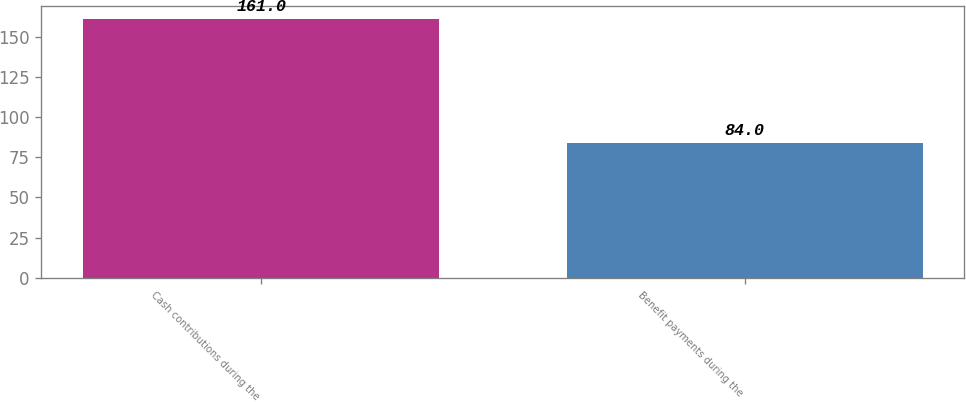Convert chart to OTSL. <chart><loc_0><loc_0><loc_500><loc_500><bar_chart><fcel>Cash contributions during the<fcel>Benefit payments during the<nl><fcel>161<fcel>84<nl></chart> 